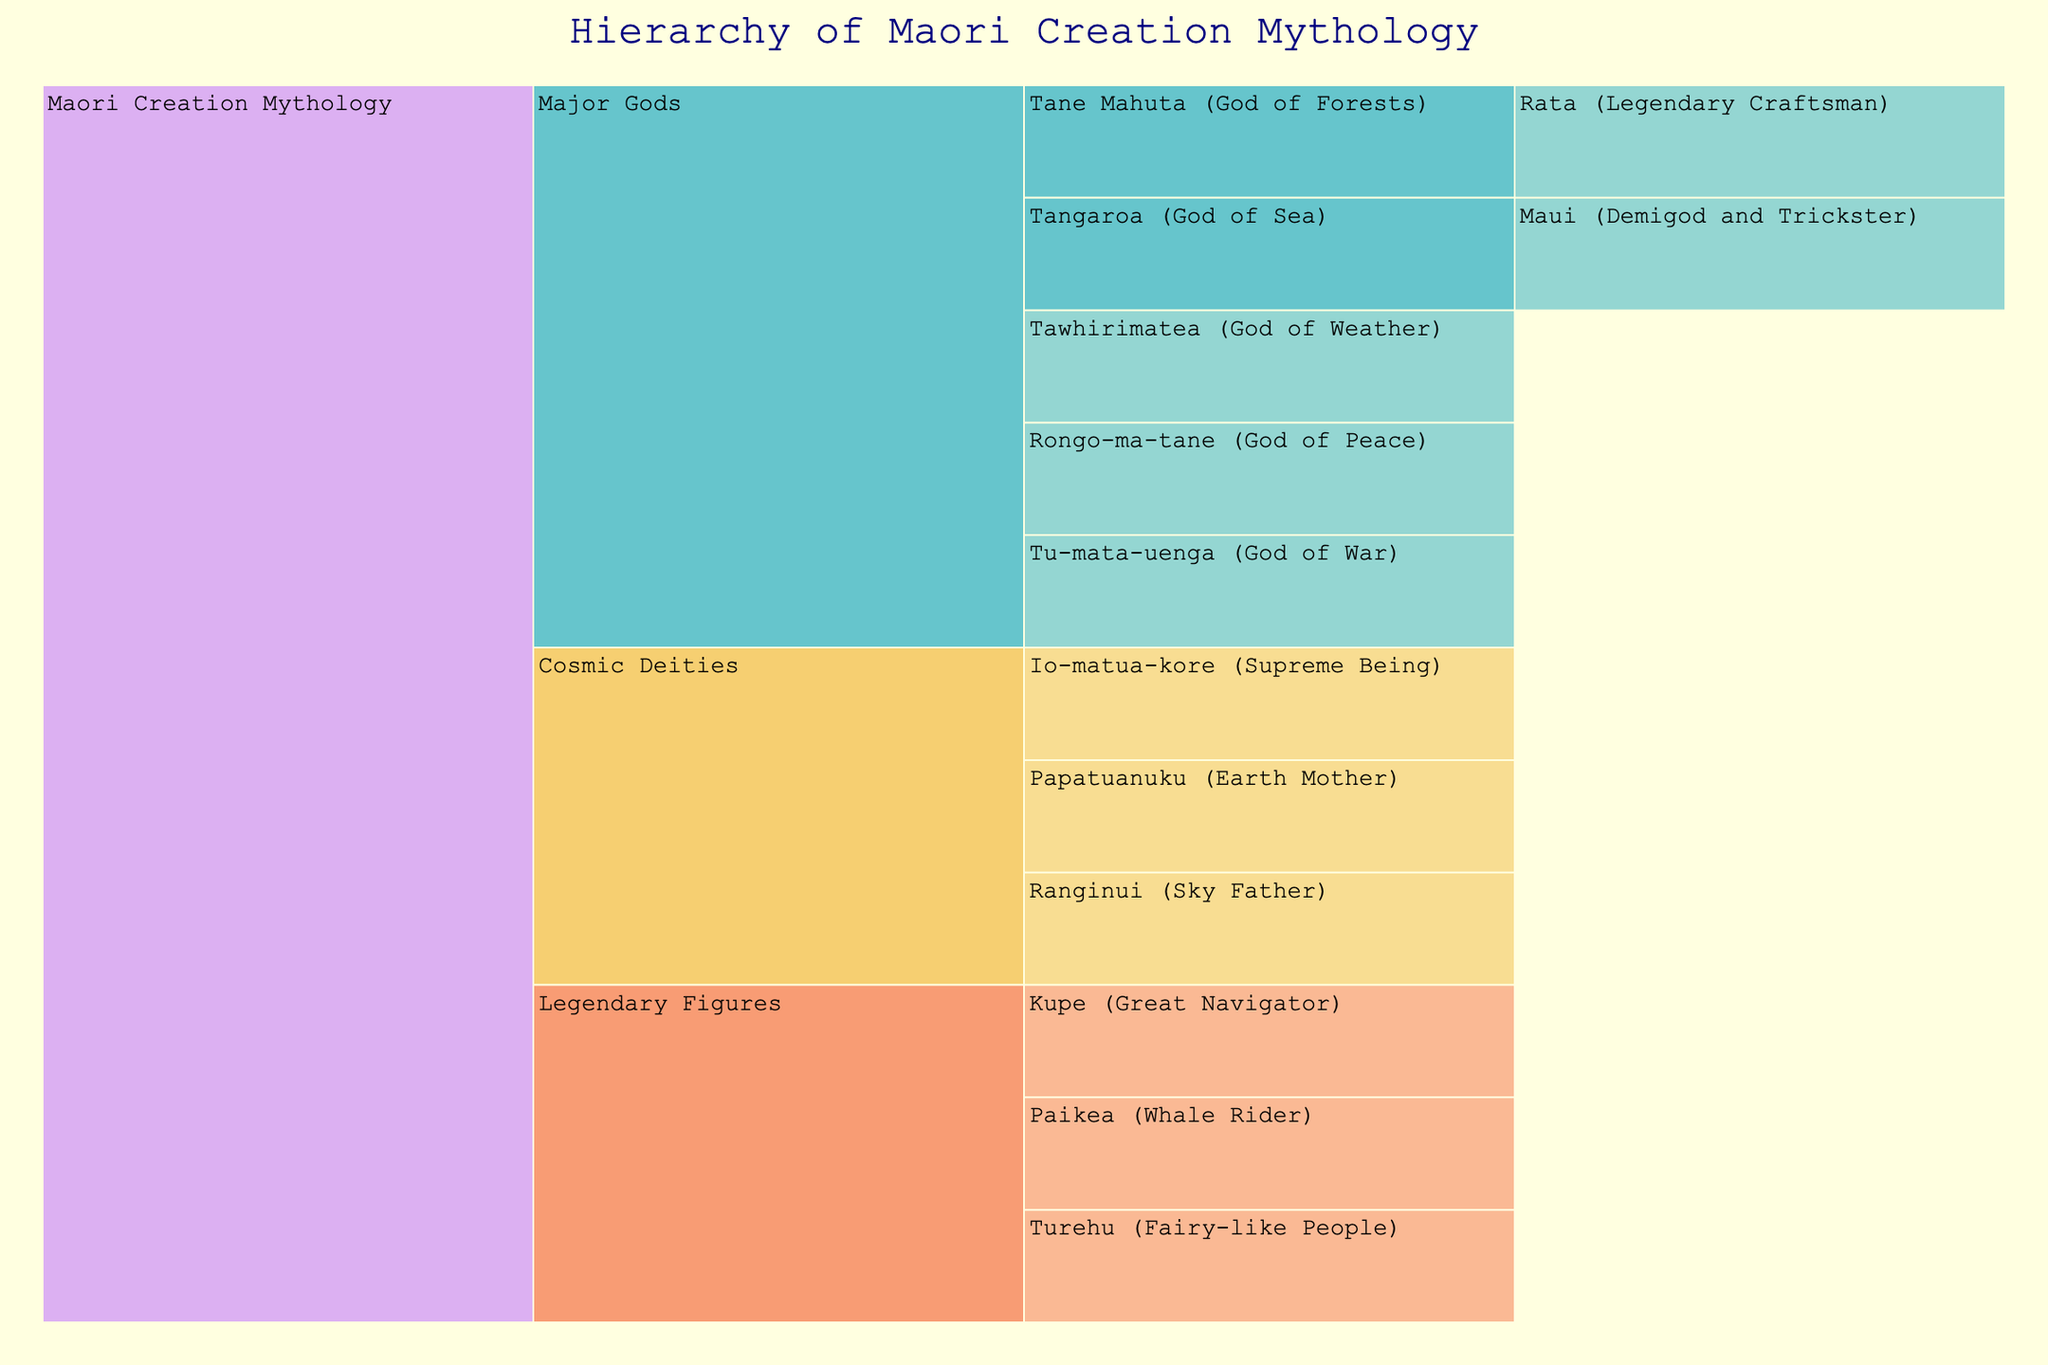what is the supreme being called in the Maori creation mythology? Look at the first level under "Cosmic Deities" where the supreme being is listed.
Answer: Io-matua-kore What are the two figures that represent the Sky and the Earth in Maori creation mythology? Check the "Cosmic Deities" section for the Sky Father and Earth Mother.
Answer: Ranginui and Papatuanuku Which god is identified as the God of Forests, and who is his notable descendant? Look in the "Major Gods" section under "Tane Mahuta" and then see the associated name in the next level.
Answer: Tane Mahuta and Rata Name the demigod and trickster related to the God of the Sea in Maori mythology. Go to the "Major Gods" section and locate "Tangaroa," then identify the next level under him.
Answer: Maui Who is the legendary figure known as the "Whale Rider"? Check the "Legendary Figures" section, and find the name associated with "Whale Rider."
Answer: Paikea How many major gods are depicted in the hierarchy of Maori creation mythology? Count the number of distinct entities listed under the "Major Gods" section.
Answer: Five Which major god is associated with the concept of peace in Maori mythology? Look in the "Major Gods" section for the god associated with peace.
Answer: Rongo-ma-tane Compare the level of specificity in the "Legendary Figures" and "Cosmic Deities" sections. Which section provides more detailed hierarchical levels? Note the depth of hierarchy, starting from the root down to lower levels, in both "Cosmic Deities" and "Legendary Figures".
Answer: Legendary Figures How does the hierarchy differentiate between gods and legendary figures in the chart? Observe how the chart organizes the figures into groups and use labels and levels to infer the distinction.
Answer: Gods are under "Major Gods" and legendary figures under "Legendary Figures." Who is the great navigator in Maori creation mythology as per the icicle chart? Refer to the "Legendary Figures" section, and identify the figure known as the navigator.
Answer: Kupe 